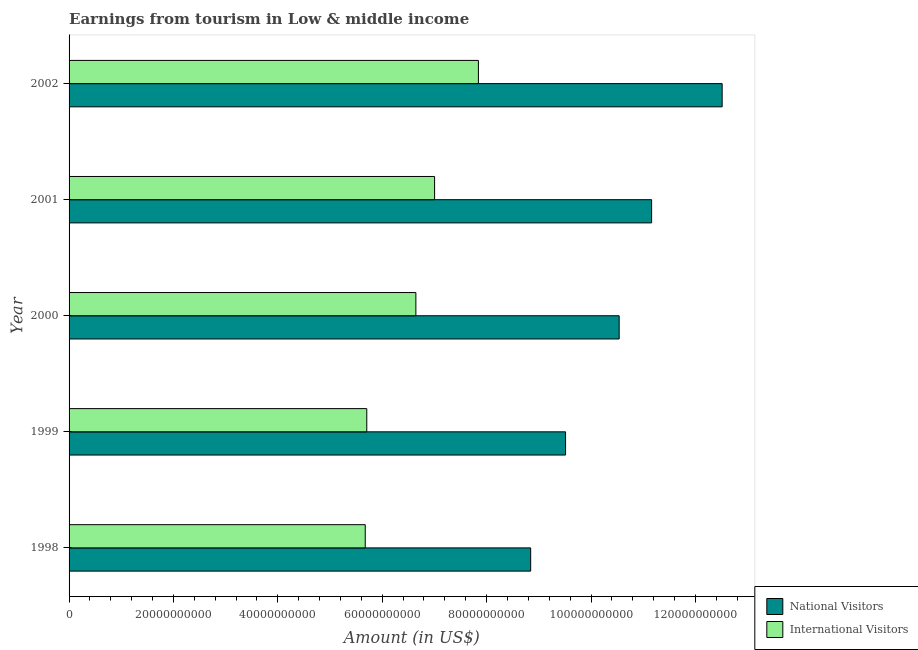How many different coloured bars are there?
Give a very brief answer. 2. How many bars are there on the 5th tick from the top?
Your answer should be compact. 2. What is the label of the 5th group of bars from the top?
Keep it short and to the point. 1998. What is the amount earned from national visitors in 1999?
Give a very brief answer. 9.51e+1. Across all years, what is the maximum amount earned from national visitors?
Your response must be concise. 1.25e+11. Across all years, what is the minimum amount earned from international visitors?
Your answer should be very brief. 5.67e+1. What is the total amount earned from international visitors in the graph?
Offer a very short reply. 3.29e+11. What is the difference between the amount earned from international visitors in 1998 and that in 1999?
Offer a terse response. -2.91e+08. What is the difference between the amount earned from international visitors in 2001 and the amount earned from national visitors in 1998?
Your answer should be compact. -1.84e+1. What is the average amount earned from international visitors per year?
Provide a succinct answer. 6.57e+1. In the year 1999, what is the difference between the amount earned from national visitors and amount earned from international visitors?
Your answer should be very brief. 3.81e+1. In how many years, is the amount earned from national visitors greater than 68000000000 US$?
Your answer should be compact. 5. What is the ratio of the amount earned from national visitors in 2000 to that in 2001?
Provide a short and direct response. 0.94. Is the difference between the amount earned from national visitors in 1999 and 2000 greater than the difference between the amount earned from international visitors in 1999 and 2000?
Keep it short and to the point. No. What is the difference between the highest and the second highest amount earned from international visitors?
Offer a terse response. 8.39e+09. What is the difference between the highest and the lowest amount earned from international visitors?
Make the answer very short. 2.17e+1. In how many years, is the amount earned from international visitors greater than the average amount earned from international visitors taken over all years?
Keep it short and to the point. 3. Is the sum of the amount earned from national visitors in 2000 and 2002 greater than the maximum amount earned from international visitors across all years?
Give a very brief answer. Yes. What does the 2nd bar from the top in 2001 represents?
Keep it short and to the point. National Visitors. What does the 1st bar from the bottom in 1998 represents?
Give a very brief answer. National Visitors. How many bars are there?
Give a very brief answer. 10. How many years are there in the graph?
Ensure brevity in your answer.  5. What is the difference between two consecutive major ticks on the X-axis?
Your answer should be very brief. 2.00e+1. Are the values on the major ticks of X-axis written in scientific E-notation?
Offer a terse response. No. Does the graph contain any zero values?
Give a very brief answer. No. Does the graph contain grids?
Your answer should be very brief. No. Where does the legend appear in the graph?
Offer a terse response. Bottom right. What is the title of the graph?
Your response must be concise. Earnings from tourism in Low & middle income. What is the label or title of the Y-axis?
Make the answer very short. Year. What is the Amount (in US$) of National Visitors in 1998?
Your response must be concise. 8.84e+1. What is the Amount (in US$) of International Visitors in 1998?
Offer a very short reply. 5.67e+1. What is the Amount (in US$) in National Visitors in 1999?
Your answer should be very brief. 9.51e+1. What is the Amount (in US$) in International Visitors in 1999?
Provide a succinct answer. 5.70e+1. What is the Amount (in US$) of National Visitors in 2000?
Provide a succinct answer. 1.05e+11. What is the Amount (in US$) of International Visitors in 2000?
Your response must be concise. 6.64e+1. What is the Amount (in US$) in National Visitors in 2001?
Give a very brief answer. 1.12e+11. What is the Amount (in US$) of International Visitors in 2001?
Your answer should be very brief. 7.00e+1. What is the Amount (in US$) of National Visitors in 2002?
Your response must be concise. 1.25e+11. What is the Amount (in US$) in International Visitors in 2002?
Your answer should be compact. 7.84e+1. Across all years, what is the maximum Amount (in US$) of National Visitors?
Provide a short and direct response. 1.25e+11. Across all years, what is the maximum Amount (in US$) in International Visitors?
Provide a succinct answer. 7.84e+1. Across all years, what is the minimum Amount (in US$) in National Visitors?
Make the answer very short. 8.84e+1. Across all years, what is the minimum Amount (in US$) in International Visitors?
Your answer should be very brief. 5.67e+1. What is the total Amount (in US$) of National Visitors in the graph?
Give a very brief answer. 5.26e+11. What is the total Amount (in US$) in International Visitors in the graph?
Your answer should be compact. 3.29e+11. What is the difference between the Amount (in US$) in National Visitors in 1998 and that in 1999?
Your answer should be compact. -6.69e+09. What is the difference between the Amount (in US$) of International Visitors in 1998 and that in 1999?
Your answer should be compact. -2.91e+08. What is the difference between the Amount (in US$) of National Visitors in 1998 and that in 2000?
Provide a succinct answer. -1.70e+1. What is the difference between the Amount (in US$) in International Visitors in 1998 and that in 2000?
Make the answer very short. -9.70e+09. What is the difference between the Amount (in US$) in National Visitors in 1998 and that in 2001?
Make the answer very short. -2.32e+1. What is the difference between the Amount (in US$) in International Visitors in 1998 and that in 2001?
Your answer should be very brief. -1.33e+1. What is the difference between the Amount (in US$) in National Visitors in 1998 and that in 2002?
Your answer should be compact. -3.67e+1. What is the difference between the Amount (in US$) of International Visitors in 1998 and that in 2002?
Offer a terse response. -2.17e+1. What is the difference between the Amount (in US$) in National Visitors in 1999 and that in 2000?
Offer a very short reply. -1.03e+1. What is the difference between the Amount (in US$) in International Visitors in 1999 and that in 2000?
Your answer should be compact. -9.41e+09. What is the difference between the Amount (in US$) of National Visitors in 1999 and that in 2001?
Offer a terse response. -1.65e+1. What is the difference between the Amount (in US$) in International Visitors in 1999 and that in 2001?
Provide a succinct answer. -1.30e+1. What is the difference between the Amount (in US$) of National Visitors in 1999 and that in 2002?
Ensure brevity in your answer.  -3.00e+1. What is the difference between the Amount (in US$) in International Visitors in 1999 and that in 2002?
Give a very brief answer. -2.14e+1. What is the difference between the Amount (in US$) in National Visitors in 2000 and that in 2001?
Offer a terse response. -6.22e+09. What is the difference between the Amount (in US$) of International Visitors in 2000 and that in 2001?
Your answer should be very brief. -3.59e+09. What is the difference between the Amount (in US$) of National Visitors in 2000 and that in 2002?
Your response must be concise. -1.97e+1. What is the difference between the Amount (in US$) of International Visitors in 2000 and that in 2002?
Your response must be concise. -1.20e+1. What is the difference between the Amount (in US$) of National Visitors in 2001 and that in 2002?
Give a very brief answer. -1.35e+1. What is the difference between the Amount (in US$) of International Visitors in 2001 and that in 2002?
Provide a succinct answer. -8.39e+09. What is the difference between the Amount (in US$) in National Visitors in 1998 and the Amount (in US$) in International Visitors in 1999?
Ensure brevity in your answer.  3.14e+1. What is the difference between the Amount (in US$) of National Visitors in 1998 and the Amount (in US$) of International Visitors in 2000?
Your answer should be compact. 2.20e+1. What is the difference between the Amount (in US$) in National Visitors in 1998 and the Amount (in US$) in International Visitors in 2001?
Your answer should be very brief. 1.84e+1. What is the difference between the Amount (in US$) in National Visitors in 1998 and the Amount (in US$) in International Visitors in 2002?
Make the answer very short. 1.00e+1. What is the difference between the Amount (in US$) of National Visitors in 1999 and the Amount (in US$) of International Visitors in 2000?
Your answer should be very brief. 2.87e+1. What is the difference between the Amount (in US$) in National Visitors in 1999 and the Amount (in US$) in International Visitors in 2001?
Give a very brief answer. 2.51e+1. What is the difference between the Amount (in US$) of National Visitors in 1999 and the Amount (in US$) of International Visitors in 2002?
Give a very brief answer. 1.67e+1. What is the difference between the Amount (in US$) of National Visitors in 2000 and the Amount (in US$) of International Visitors in 2001?
Provide a short and direct response. 3.54e+1. What is the difference between the Amount (in US$) of National Visitors in 2000 and the Amount (in US$) of International Visitors in 2002?
Provide a succinct answer. 2.70e+1. What is the difference between the Amount (in US$) of National Visitors in 2001 and the Amount (in US$) of International Visitors in 2002?
Your answer should be very brief. 3.32e+1. What is the average Amount (in US$) in National Visitors per year?
Provide a short and direct response. 1.05e+11. What is the average Amount (in US$) of International Visitors per year?
Offer a terse response. 6.57e+1. In the year 1998, what is the difference between the Amount (in US$) of National Visitors and Amount (in US$) of International Visitors?
Keep it short and to the point. 3.17e+1. In the year 1999, what is the difference between the Amount (in US$) of National Visitors and Amount (in US$) of International Visitors?
Offer a very short reply. 3.81e+1. In the year 2000, what is the difference between the Amount (in US$) in National Visitors and Amount (in US$) in International Visitors?
Your response must be concise. 3.90e+1. In the year 2001, what is the difference between the Amount (in US$) in National Visitors and Amount (in US$) in International Visitors?
Provide a short and direct response. 4.16e+1. In the year 2002, what is the difference between the Amount (in US$) of National Visitors and Amount (in US$) of International Visitors?
Your answer should be very brief. 4.67e+1. What is the ratio of the Amount (in US$) of National Visitors in 1998 to that in 1999?
Provide a succinct answer. 0.93. What is the ratio of the Amount (in US$) in National Visitors in 1998 to that in 2000?
Give a very brief answer. 0.84. What is the ratio of the Amount (in US$) in International Visitors in 1998 to that in 2000?
Your answer should be compact. 0.85. What is the ratio of the Amount (in US$) of National Visitors in 1998 to that in 2001?
Provide a short and direct response. 0.79. What is the ratio of the Amount (in US$) of International Visitors in 1998 to that in 2001?
Make the answer very short. 0.81. What is the ratio of the Amount (in US$) of National Visitors in 1998 to that in 2002?
Provide a short and direct response. 0.71. What is the ratio of the Amount (in US$) of International Visitors in 1998 to that in 2002?
Your response must be concise. 0.72. What is the ratio of the Amount (in US$) of National Visitors in 1999 to that in 2000?
Make the answer very short. 0.9. What is the ratio of the Amount (in US$) in International Visitors in 1999 to that in 2000?
Your answer should be very brief. 0.86. What is the ratio of the Amount (in US$) of National Visitors in 1999 to that in 2001?
Ensure brevity in your answer.  0.85. What is the ratio of the Amount (in US$) of International Visitors in 1999 to that in 2001?
Offer a very short reply. 0.81. What is the ratio of the Amount (in US$) in National Visitors in 1999 to that in 2002?
Provide a succinct answer. 0.76. What is the ratio of the Amount (in US$) in International Visitors in 1999 to that in 2002?
Provide a short and direct response. 0.73. What is the ratio of the Amount (in US$) of National Visitors in 2000 to that in 2001?
Your answer should be compact. 0.94. What is the ratio of the Amount (in US$) in International Visitors in 2000 to that in 2001?
Ensure brevity in your answer.  0.95. What is the ratio of the Amount (in US$) in National Visitors in 2000 to that in 2002?
Ensure brevity in your answer.  0.84. What is the ratio of the Amount (in US$) in International Visitors in 2000 to that in 2002?
Offer a terse response. 0.85. What is the ratio of the Amount (in US$) in National Visitors in 2001 to that in 2002?
Provide a short and direct response. 0.89. What is the ratio of the Amount (in US$) of International Visitors in 2001 to that in 2002?
Your answer should be compact. 0.89. What is the difference between the highest and the second highest Amount (in US$) in National Visitors?
Your answer should be compact. 1.35e+1. What is the difference between the highest and the second highest Amount (in US$) of International Visitors?
Your answer should be very brief. 8.39e+09. What is the difference between the highest and the lowest Amount (in US$) of National Visitors?
Provide a short and direct response. 3.67e+1. What is the difference between the highest and the lowest Amount (in US$) of International Visitors?
Keep it short and to the point. 2.17e+1. 